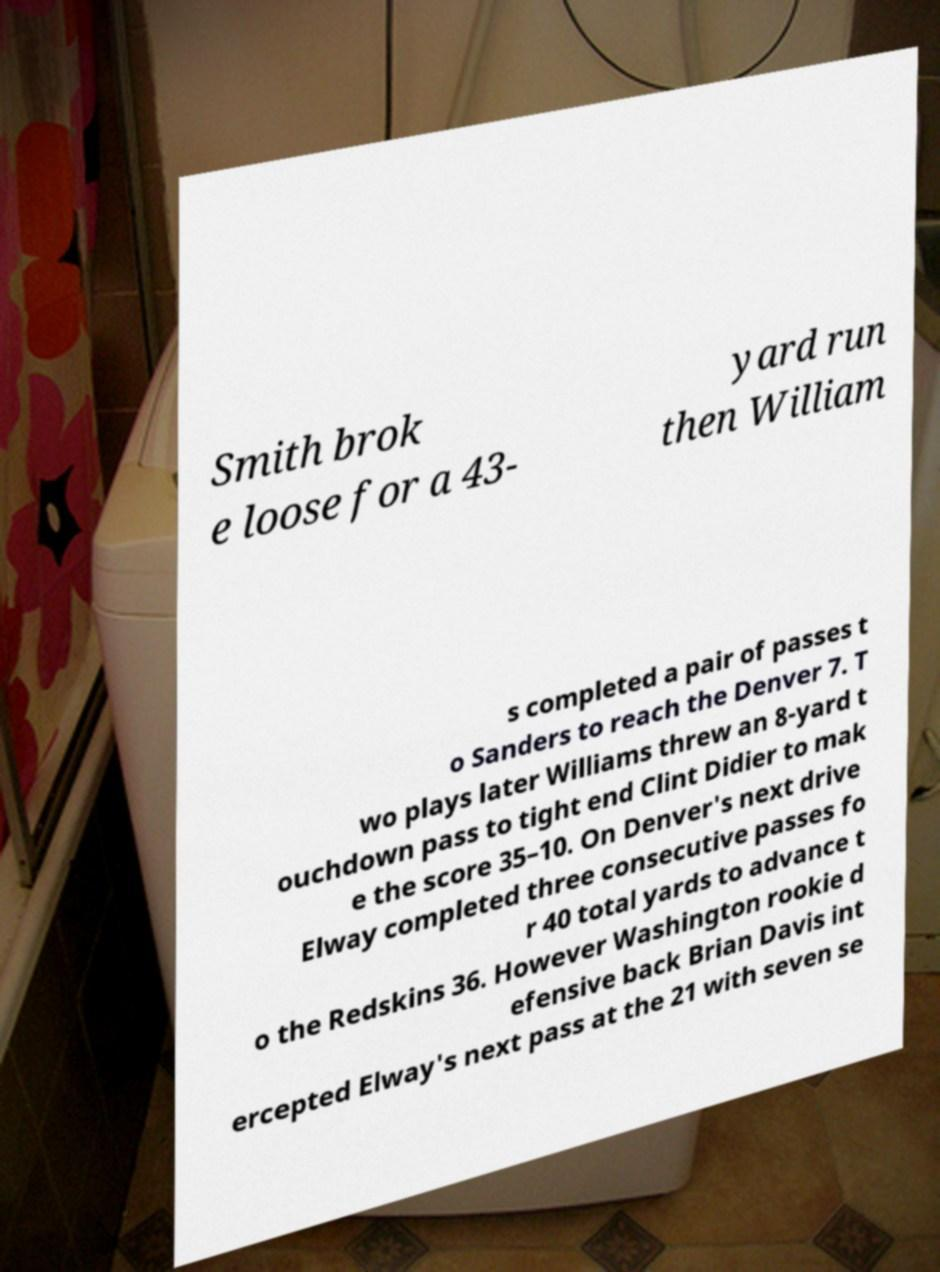Can you read and provide the text displayed in the image?This photo seems to have some interesting text. Can you extract and type it out for me? Smith brok e loose for a 43- yard run then William s completed a pair of passes t o Sanders to reach the Denver 7. T wo plays later Williams threw an 8-yard t ouchdown pass to tight end Clint Didier to mak e the score 35–10. On Denver's next drive Elway completed three consecutive passes fo r 40 total yards to advance t o the Redskins 36. However Washington rookie d efensive back Brian Davis int ercepted Elway's next pass at the 21 with seven se 